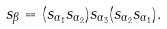<formula> <loc_0><loc_0><loc_500><loc_500>s _ { \beta } = ( s _ { \alpha _ { 1 } } s _ { \alpha _ { 2 } } ) s _ { \alpha _ { 3 } } ( s _ { \alpha _ { 2 } } s _ { \alpha _ { 1 } } ) .</formula> 